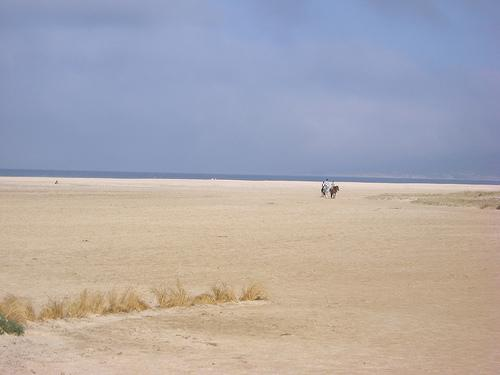Question: what color is the sand?
Choices:
A. Brown.
B. Yellow.
C. Beige.
D. Gold.
Answer with the letter. Answer: C Question: what type of body of water is there?
Choices:
A. A creek.
B. A river.
C. An ocean.
D. A pond.
Answer with the letter. Answer: C 